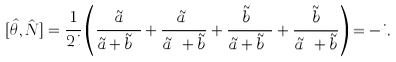<formula> <loc_0><loc_0><loc_500><loc_500>[ \hat { \theta } , \hat { N } ] = \frac { 1 } { 2 i } \left ( \frac { \tilde { a } } { \tilde { a } + \tilde { b } ^ { \dag } } + \frac { \tilde { a } ^ { \dag } } { \tilde { a } ^ { \dag } + \tilde { b } } + \frac { \tilde { b } ^ { \dag } } { \tilde { a } + \tilde { b } ^ { \dag } } + \frac { \tilde { b } } { \tilde { a } ^ { \dag } + \tilde { b } } \right ) = - i .</formula> 